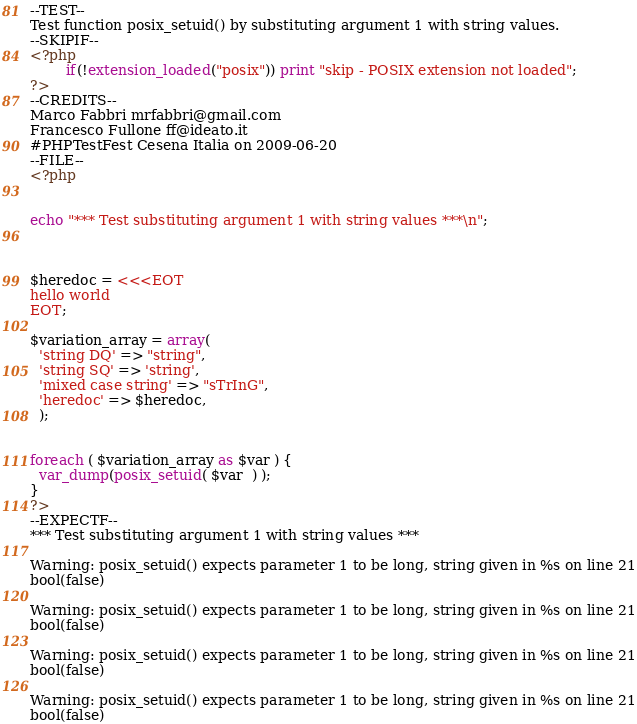<code> <loc_0><loc_0><loc_500><loc_500><_PHP_>--TEST--
Test function posix_setuid() by substituting argument 1 with string values.
--SKIPIF--
<?php 
        if(!extension_loaded("posix")) print "skip - POSIX extension not loaded"; 
?>
--CREDITS--
Marco Fabbri mrfabbri@gmail.com
Francesco Fullone ff@ideato.it
#PHPTestFest Cesena Italia on 2009-06-20
--FILE--
<?php


echo "*** Test substituting argument 1 with string values ***\n";



$heredoc = <<<EOT
hello world
EOT;

$variation_array = array(
  'string DQ' => "string",
  'string SQ' => 'string',
  'mixed case string' => "sTrInG",
  'heredoc' => $heredoc,
  );


foreach ( $variation_array as $var ) {
  var_dump(posix_setuid( $var  ) );
}
?>
--EXPECTF--
*** Test substituting argument 1 with string values ***

Warning: posix_setuid() expects parameter 1 to be long, string given in %s on line 21
bool(false)

Warning: posix_setuid() expects parameter 1 to be long, string given in %s on line 21
bool(false)

Warning: posix_setuid() expects parameter 1 to be long, string given in %s on line 21
bool(false)

Warning: posix_setuid() expects parameter 1 to be long, string given in %s on line 21
bool(false)
</code> 